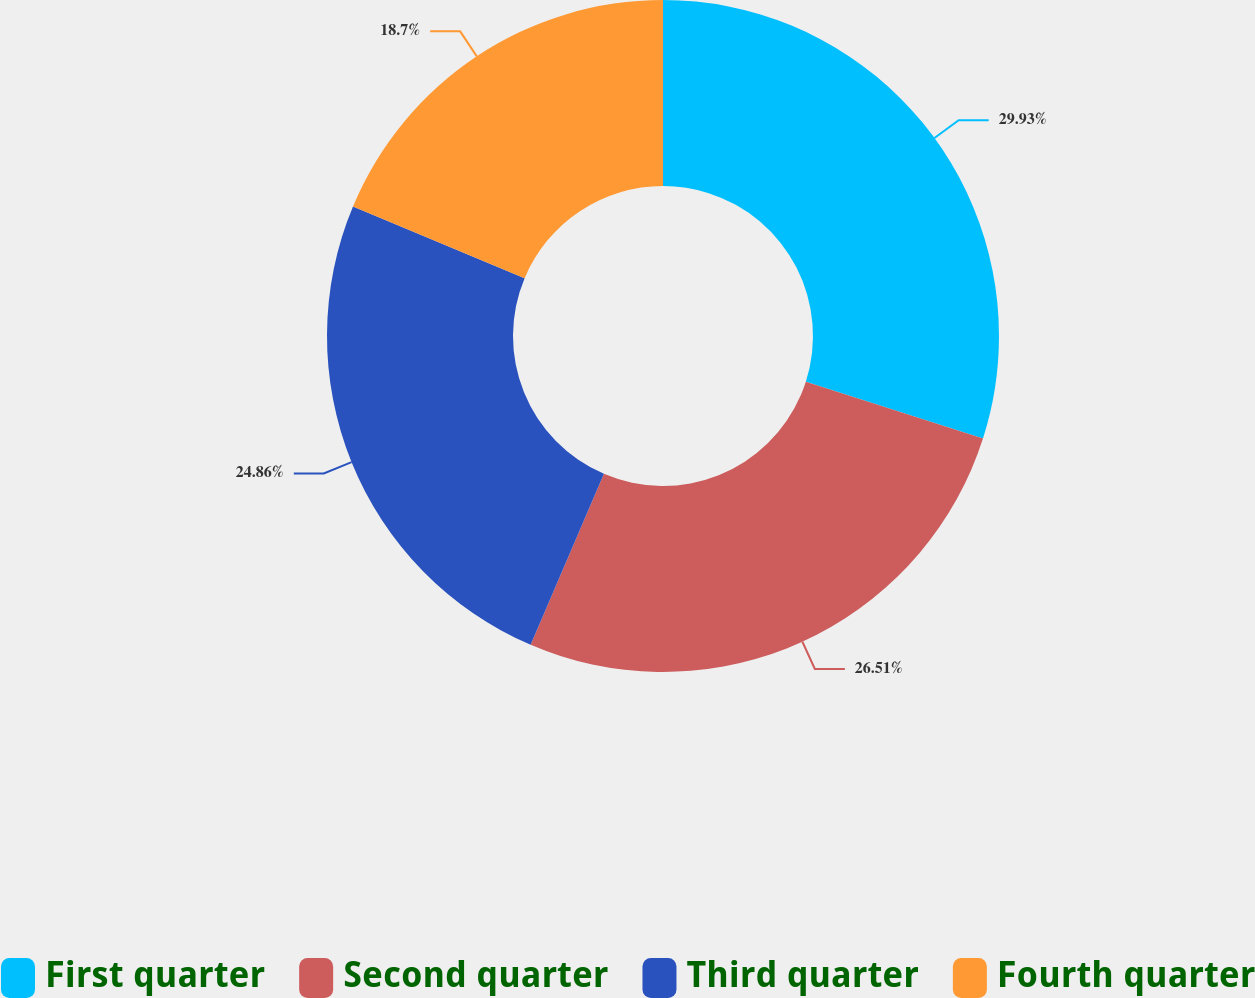Convert chart. <chart><loc_0><loc_0><loc_500><loc_500><pie_chart><fcel>First quarter<fcel>Second quarter<fcel>Third quarter<fcel>Fourth quarter<nl><fcel>29.94%<fcel>26.51%<fcel>24.86%<fcel>18.7%<nl></chart> 